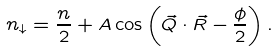<formula> <loc_0><loc_0><loc_500><loc_500>n _ { \downarrow } = \frac { n } { 2 } + A \cos \left ( \vec { Q } \cdot \vec { R } - \frac { \phi } { 2 } \right ) .</formula> 